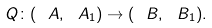Convert formula to latex. <formula><loc_0><loc_0><loc_500><loc_500>Q \colon ( \ A , \ A _ { 1 } ) \to ( \ B , \ B _ { 1 } ) .</formula> 